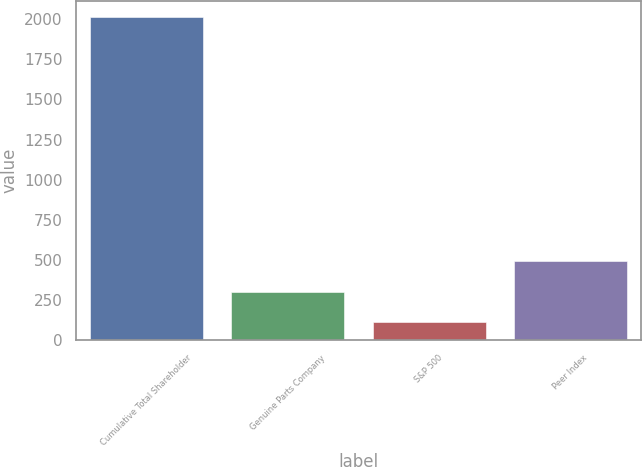<chart> <loc_0><loc_0><loc_500><loc_500><bar_chart><fcel>Cumulative Total Shareholder<fcel>Genuine Parts Company<fcel>S&P 500<fcel>Peer Index<nl><fcel>2010<fcel>301.77<fcel>111.97<fcel>491.57<nl></chart> 